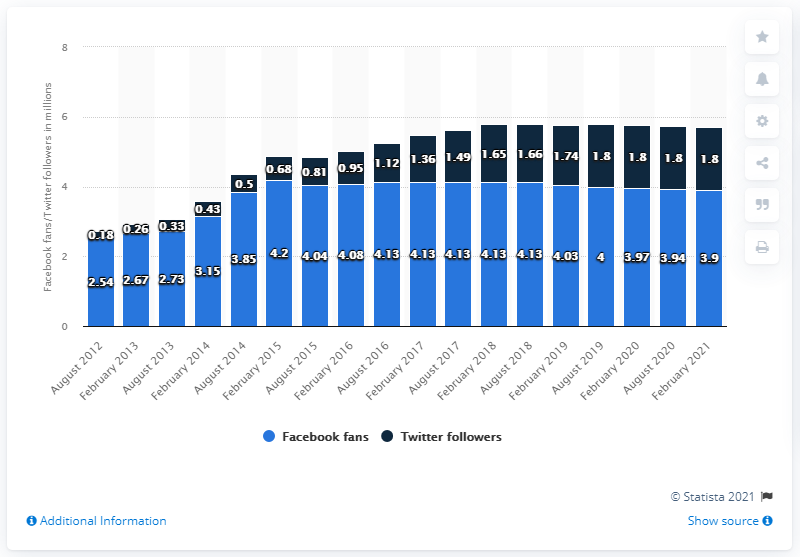Give some essential details in this illustration. The Chicago Bears' Facebook page was established in August 2012. The Chicago Bears football team had 3.9 million Facebook fans in February 2021. The Facebook page of the Chicago Bears reached 3.9 million followers in February 2021. 